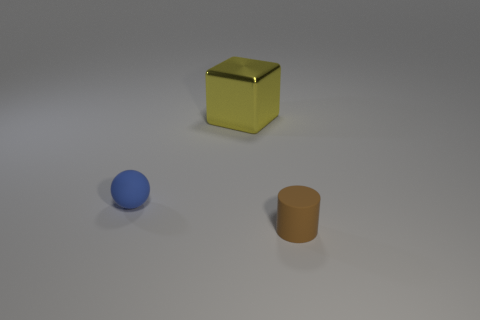Add 2 rubber spheres. How many objects exist? 5 Subtract all spheres. How many objects are left? 2 Add 1 cubes. How many cubes are left? 2 Add 2 big yellow rubber balls. How many big yellow rubber balls exist? 2 Subtract 0 yellow spheres. How many objects are left? 3 Subtract 1 blocks. How many blocks are left? 0 Subtract all purple blocks. Subtract all blue balls. How many blocks are left? 1 Subtract all red cubes. How many yellow spheres are left? 0 Subtract all large brown rubber objects. Subtract all balls. How many objects are left? 2 